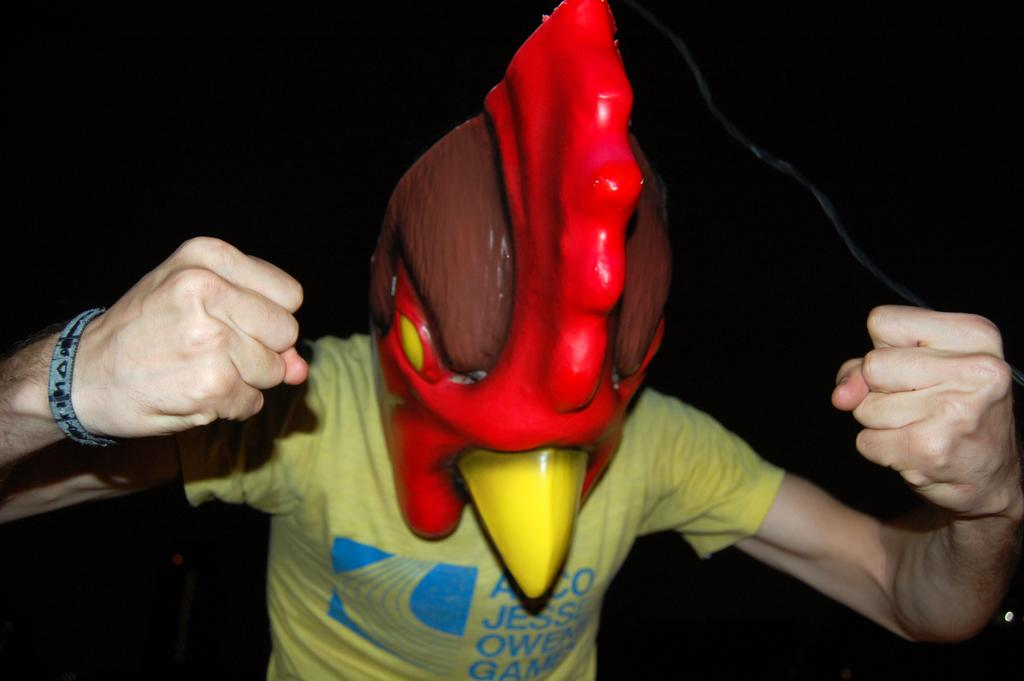What can be seen in the image? There is a person in the image. What is the person wearing on their head? The person is wearing an object on their head. Can you describe the colors of the object on the person's head? The object is red and brown in color. What type of development can be seen in the background of the image? There is no development visible in the background of the image; it only features the person wearing an object on their head. What scent is associated with the object on the person's head? There is no information about the scent of the object in the image. 